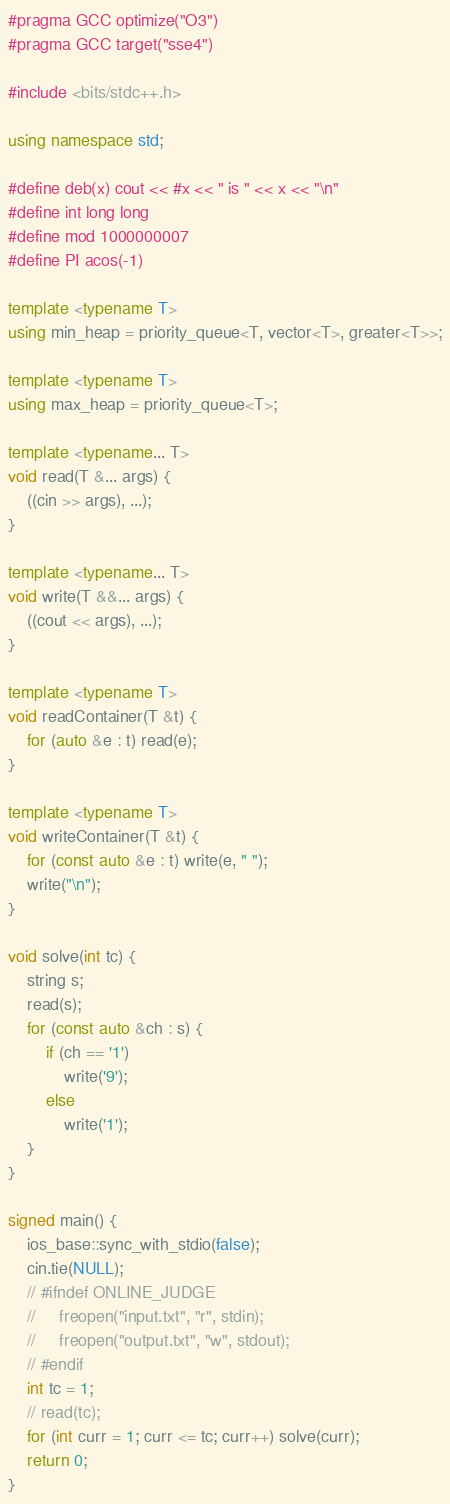Convert code to text. <code><loc_0><loc_0><loc_500><loc_500><_C++_>#pragma GCC optimize("O3")
#pragma GCC target("sse4")

#include <bits/stdc++.h>

using namespace std;

#define deb(x) cout << #x << " is " << x << "\n"
#define int long long
#define mod 1000000007
#define PI acos(-1)

template <typename T>
using min_heap = priority_queue<T, vector<T>, greater<T>>;

template <typename T>
using max_heap = priority_queue<T>;

template <typename... T>
void read(T &... args) {
    ((cin >> args), ...);
}

template <typename... T>
void write(T &&... args) {
    ((cout << args), ...);
}

template <typename T>
void readContainer(T &t) {
    for (auto &e : t) read(e);
}

template <typename T>
void writeContainer(T &t) {
    for (const auto &e : t) write(e, " ");
    write("\n");
}

void solve(int tc) {
    string s;
    read(s);
    for (const auto &ch : s) {
        if (ch == '1')
            write('9');
        else
            write('1');
    }
}

signed main() {
    ios_base::sync_with_stdio(false);
    cin.tie(NULL);
    // #ifndef ONLINE_JUDGE
    //     freopen("input.txt", "r", stdin);
    //     freopen("output.txt", "w", stdout);
    // #endif
    int tc = 1;
    // read(tc);
    for (int curr = 1; curr <= tc; curr++) solve(curr);
    return 0;
}</code> 